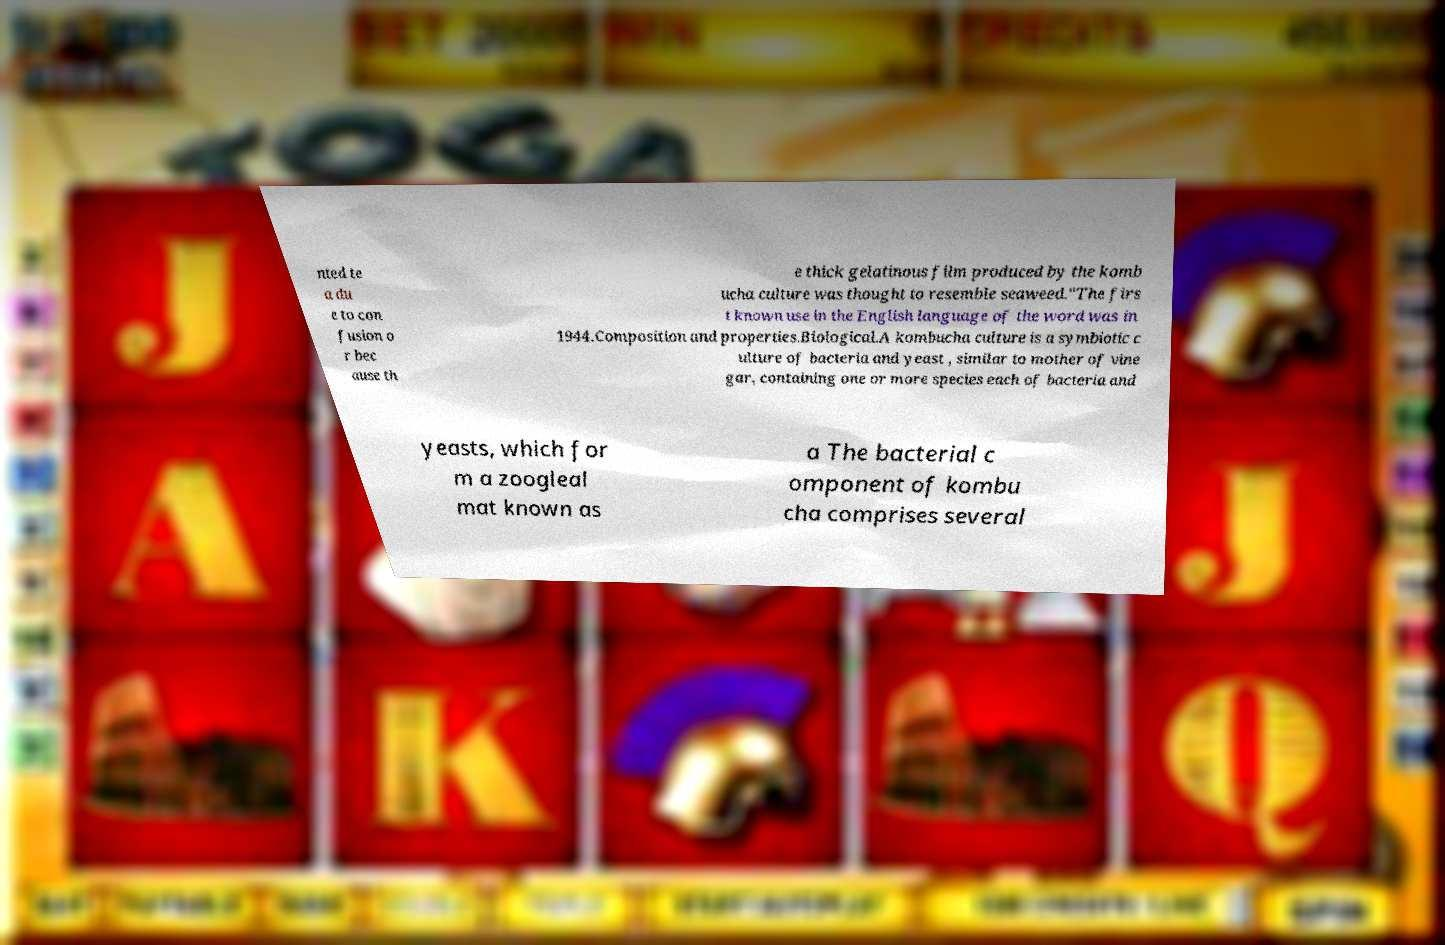For documentation purposes, I need the text within this image transcribed. Could you provide that? nted te a du e to con fusion o r bec ause th e thick gelatinous film produced by the komb ucha culture was thought to resemble seaweed."The firs t known use in the English language of the word was in 1944.Composition and properties.Biological.A kombucha culture is a symbiotic c ulture of bacteria and yeast , similar to mother of vine gar, containing one or more species each of bacteria and yeasts, which for m a zoogleal mat known as a The bacterial c omponent of kombu cha comprises several 